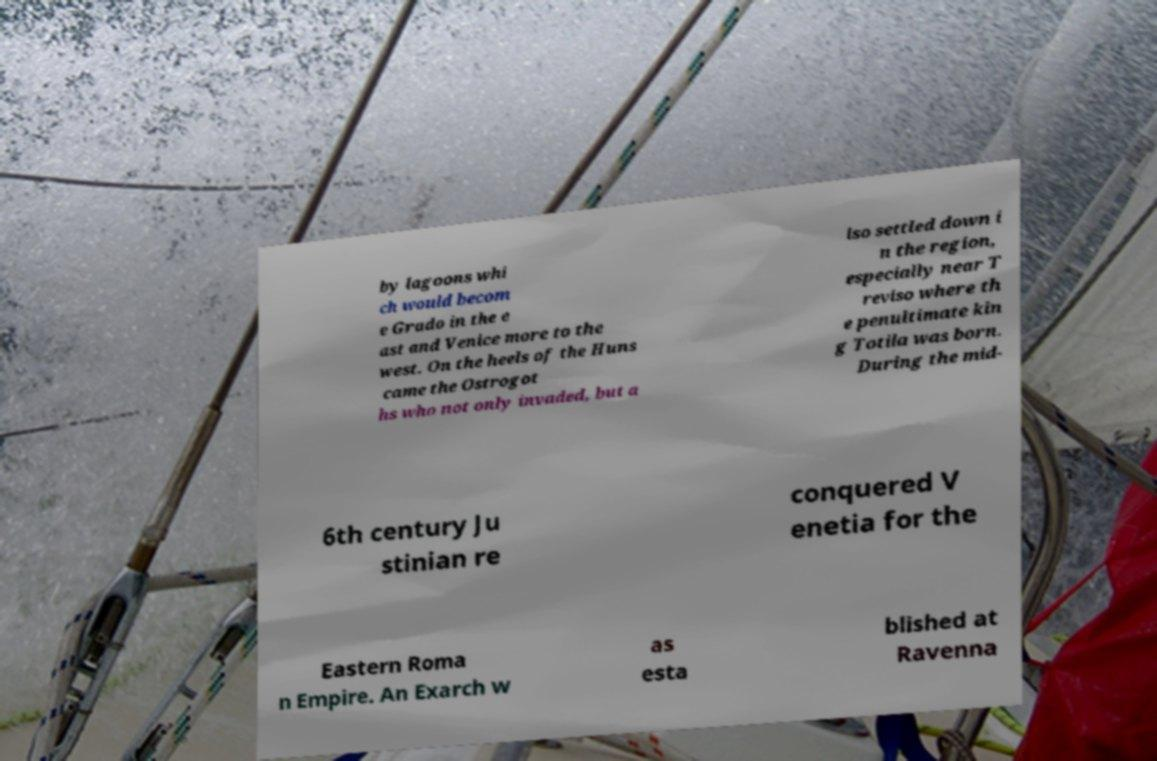Please identify and transcribe the text found in this image. by lagoons whi ch would becom e Grado in the e ast and Venice more to the west. On the heels of the Huns came the Ostrogot hs who not only invaded, but a lso settled down i n the region, especially near T reviso where th e penultimate kin g Totila was born. During the mid- 6th century Ju stinian re conquered V enetia for the Eastern Roma n Empire. An Exarch w as esta blished at Ravenna 